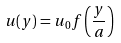Convert formula to latex. <formula><loc_0><loc_0><loc_500><loc_500>u ( y ) = u _ { 0 } f \left ( \frac { y } { a } \right )</formula> 